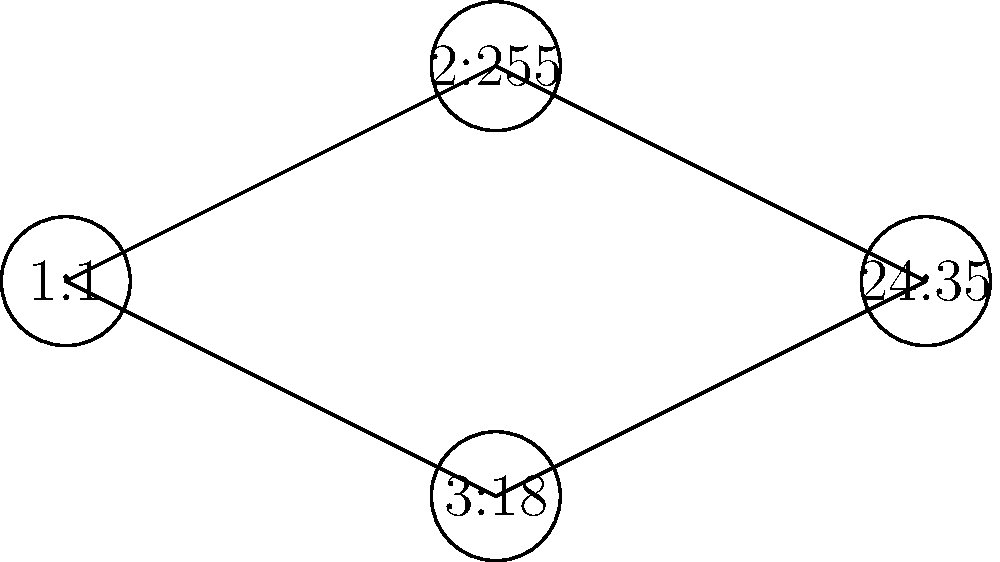In the network of Quranic verses shown above, each node represents a specific verse identified by its surah and ayah numbers. The edges connecting the nodes indicate thematic or linguistic relationships between the verses. Based on this representation, what is the degree of the node representing verse 24:35 (Ayat an-Nur), and what does this suggest about its significance in the Quranic network? To answer this question, we need to follow these steps:

1. Understand the concept of degree in graph theory:
   The degree of a node in a graph is the number of edges connected to it.

2. Identify the node representing verse 24:35:
   In the graph, the node labeled "24:35" represents Ayat an-Nur.

3. Count the number of edges connected to the "24:35" node:
   We can see that there are two edges connected to this node.

4. Determine the degree:
   Since there are two edges connected to the "24:35" node, its degree is 2.

5. Interpret the significance:
   A degree of 2 suggests that Ayat an-Nur (24:35) has direct thematic or linguistic connections with two other verses in this network. This indicates that it plays a significant role in connecting different concepts or themes within the Quran.

   In Islamic studies, Ayat an-Nur is indeed known for its profound meaning and connections to other Quranic concepts. It describes Allah as the Light of the heavens and the earth, using a powerful metaphor that relates to many other verses discussing divine guidance, knowledge, and the nature of faith.

6. Consider the limitations:
   It's important to note that this graph is a simplified representation and does not show all possible connections in the entire Quran. A more comprehensive analysis would likely reveal even more connections for this significant verse.
Answer: Degree 2, indicating significant thematic connections 